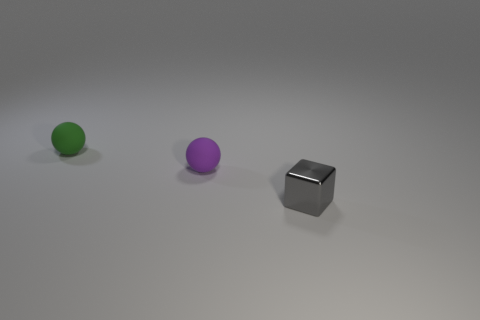Are there any objects made of the same material as the tiny purple sphere?
Your answer should be compact. Yes. The thing that is both in front of the green thing and to the left of the small gray block has what shape?
Make the answer very short. Sphere. What number of small objects are metal objects or green balls?
Offer a very short reply. 2. What is the green thing made of?
Your answer should be very brief. Rubber. What number of other objects are the same shape as the tiny gray metallic thing?
Provide a short and direct response. 0. The gray metallic cube is what size?
Offer a very short reply. Small. What size is the object that is both to the right of the green rubber object and behind the shiny object?
Your answer should be compact. Small. What is the shape of the rubber object that is behind the small purple thing?
Provide a short and direct response. Sphere. Does the tiny purple object have the same material as the thing that is behind the purple matte sphere?
Ensure brevity in your answer.  Yes. Is the shape of the tiny purple thing the same as the small green object?
Make the answer very short. Yes. 